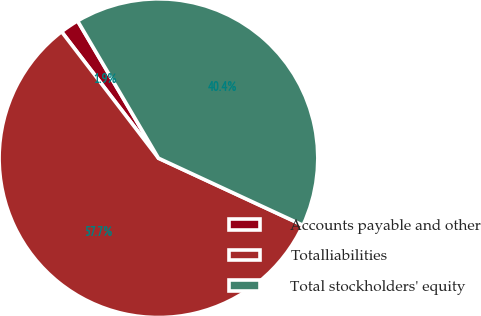Convert chart. <chart><loc_0><loc_0><loc_500><loc_500><pie_chart><fcel>Accounts payable and other<fcel>Totalliabilities<fcel>Total stockholders' equity<nl><fcel>1.93%<fcel>57.68%<fcel>40.39%<nl></chart> 